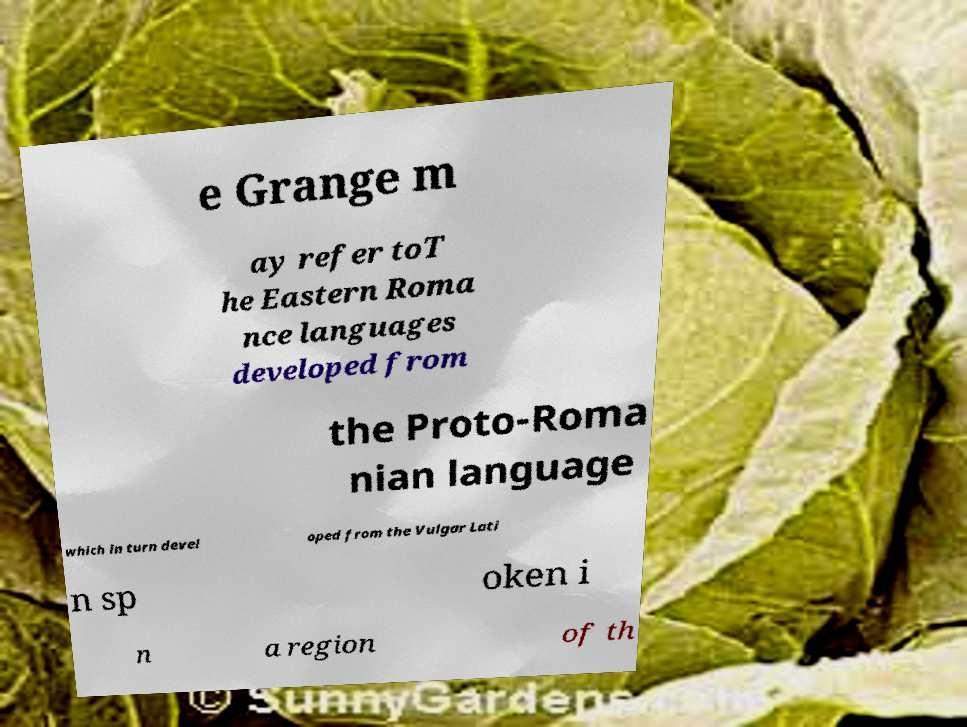Please identify and transcribe the text found in this image. e Grange m ay refer toT he Eastern Roma nce languages developed from the Proto-Roma nian language which in turn devel oped from the Vulgar Lati n sp oken i n a region of th 